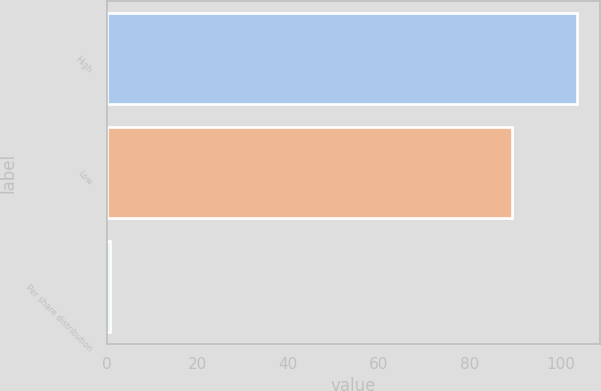Convert chart to OTSL. <chart><loc_0><loc_0><loc_500><loc_500><bar_chart><fcel>High<fcel>Low<fcel>Per share distribution<nl><fcel>103.6<fcel>89.43<fcel>0.8<nl></chart> 